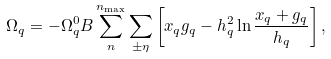<formula> <loc_0><loc_0><loc_500><loc_500>\Omega _ { q } = - \Omega ^ { 0 } _ { q } B \sum _ { n } ^ { n _ { \max } } \sum _ { \pm \eta } \left [ x _ { q } g _ { q } - h _ { q } ^ { 2 } \ln \frac { x _ { q } + g _ { q } } { h _ { q } } \right ] ,</formula> 